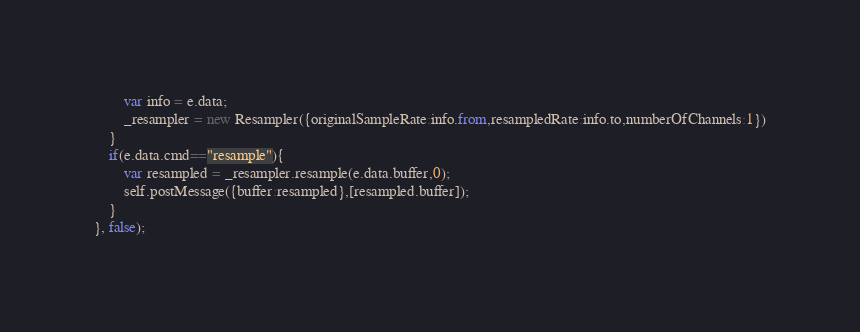<code> <loc_0><loc_0><loc_500><loc_500><_JavaScript_>        var info = e.data;
        _resampler = new Resampler({originalSampleRate:info.from,resampledRate:info.to,numberOfChannels:1})
    }
    if(e.data.cmd=="resample"){
        var resampled = _resampler.resample(e.data.buffer,0);
        self.postMessage({buffer:resampled},[resampled.buffer]);
    }
}, false);</code> 